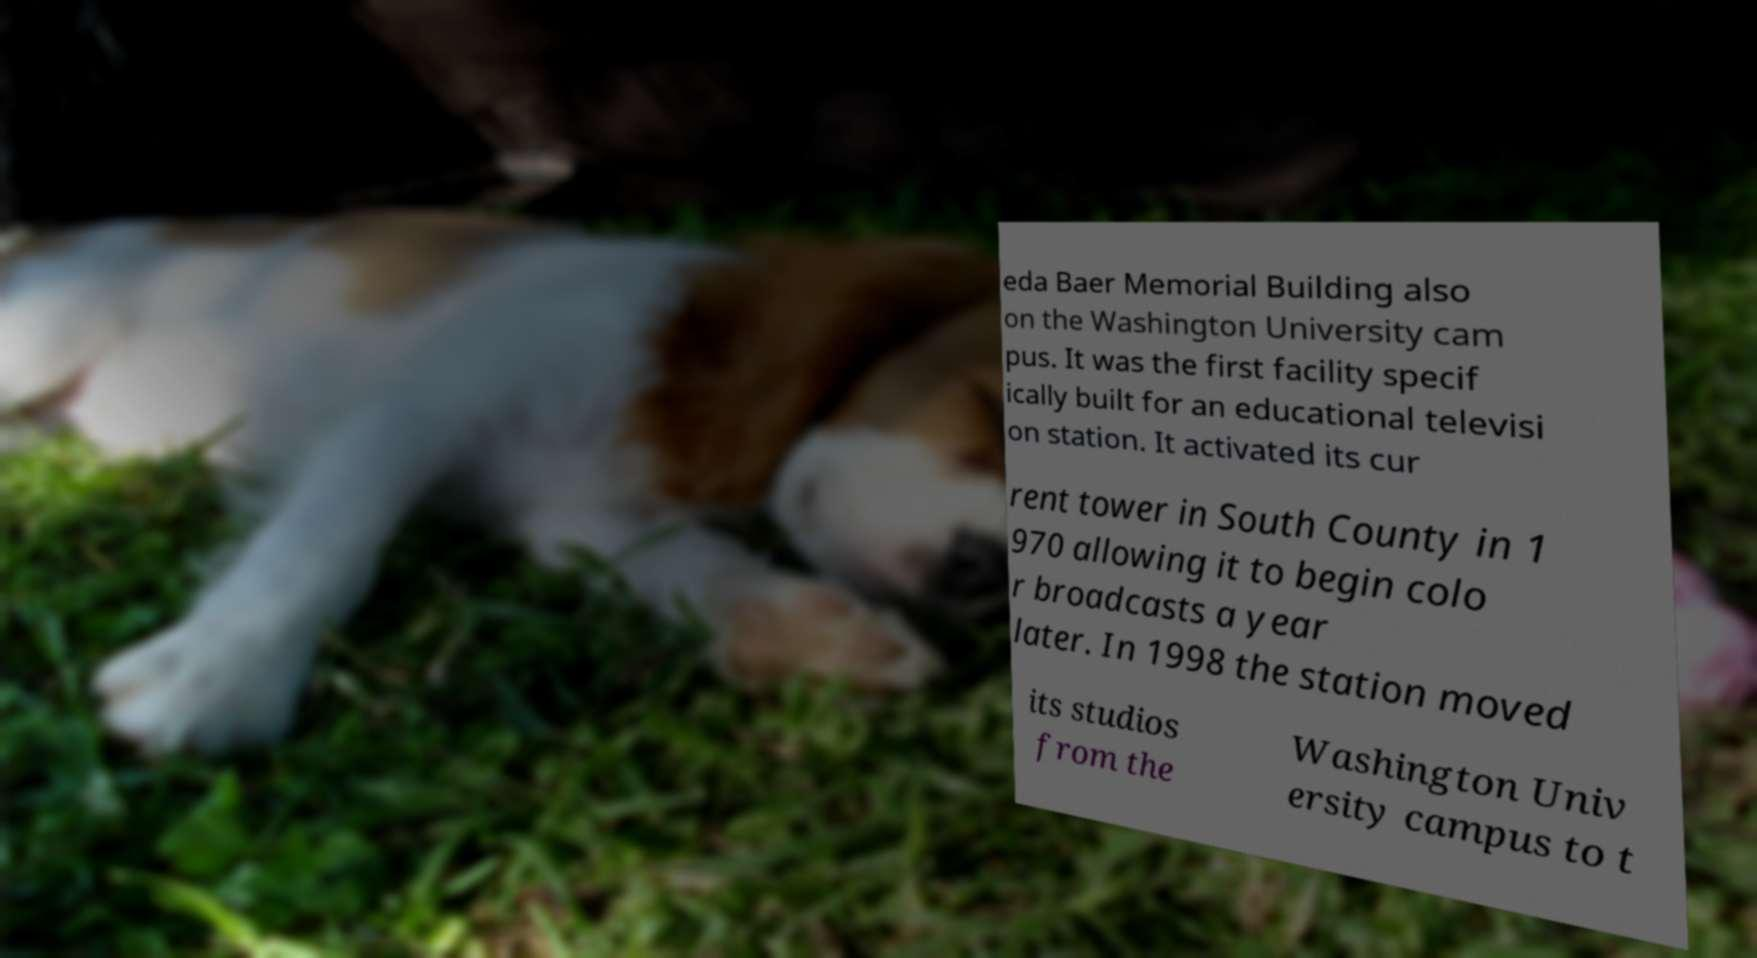I need the written content from this picture converted into text. Can you do that? eda Baer Memorial Building also on the Washington University cam pus. It was the first facility specif ically built for an educational televisi on station. It activated its cur rent tower in South County in 1 970 allowing it to begin colo r broadcasts a year later. In 1998 the station moved its studios from the Washington Univ ersity campus to t 